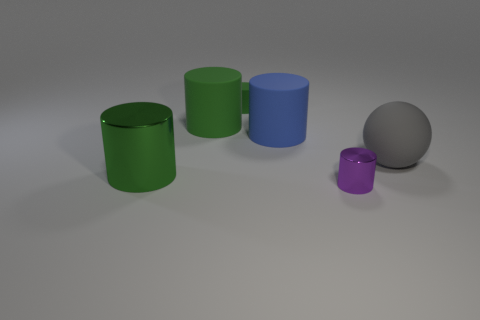There is another matte thing that is the same color as the small matte thing; what shape is it?
Your response must be concise. Cylinder. What is the color of the other small object that is the same shape as the small green thing?
Make the answer very short. Purple. How many tiny metallic things have the same color as the large metal thing?
Your response must be concise. 0. Do the gray matte sphere and the purple cylinder have the same size?
Make the answer very short. No. What material is the big gray object?
Offer a very short reply. Rubber. What is the color of the other big object that is made of the same material as the purple object?
Your response must be concise. Green. Do the small purple thing and the tiny cylinder behind the small purple object have the same material?
Make the answer very short. No. What number of big green cylinders are the same material as the large blue object?
Ensure brevity in your answer.  1. What shape is the object in front of the big green metal cylinder?
Ensure brevity in your answer.  Cylinder. Is the material of the tiny thing that is right of the small green matte cylinder the same as the big blue cylinder that is in front of the small matte thing?
Your response must be concise. No. 